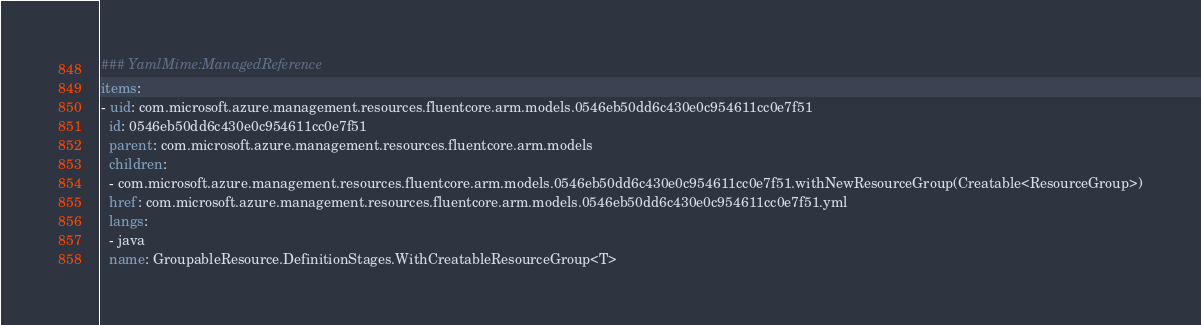Convert code to text. <code><loc_0><loc_0><loc_500><loc_500><_YAML_>### YamlMime:ManagedReference
items:
- uid: com.microsoft.azure.management.resources.fluentcore.arm.models.0546eb50dd6c430e0c954611cc0e7f51
  id: 0546eb50dd6c430e0c954611cc0e7f51
  parent: com.microsoft.azure.management.resources.fluentcore.arm.models
  children:
  - com.microsoft.azure.management.resources.fluentcore.arm.models.0546eb50dd6c430e0c954611cc0e7f51.withNewResourceGroup(Creatable<ResourceGroup>)
  href: com.microsoft.azure.management.resources.fluentcore.arm.models.0546eb50dd6c430e0c954611cc0e7f51.yml
  langs:
  - java
  name: GroupableResource.DefinitionStages.WithCreatableResourceGroup<T></code> 